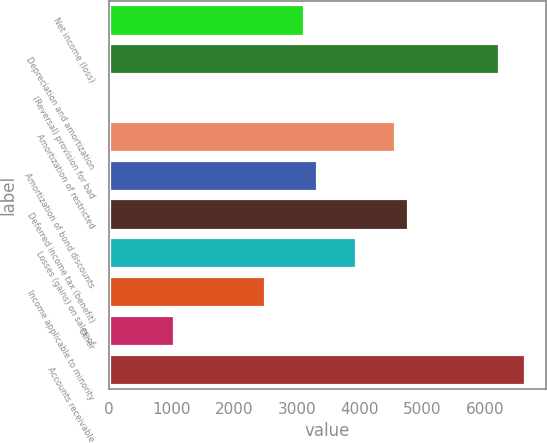Convert chart. <chart><loc_0><loc_0><loc_500><loc_500><bar_chart><fcel>Net income (loss)<fcel>Depreciation and amortization<fcel>(Reversal) provision for bad<fcel>Amortization of restricted<fcel>Amortization of bond discounts<fcel>Deferred income tax (benefit)<fcel>Losses (gains) on sales of<fcel>Income applicable to minority<fcel>Other<fcel>Accounts receivable<nl><fcel>3113.25<fcel>6225.3<fcel>1.2<fcel>4565.54<fcel>3320.72<fcel>4773.01<fcel>3943.13<fcel>2490.84<fcel>1038.55<fcel>6640.24<nl></chart> 